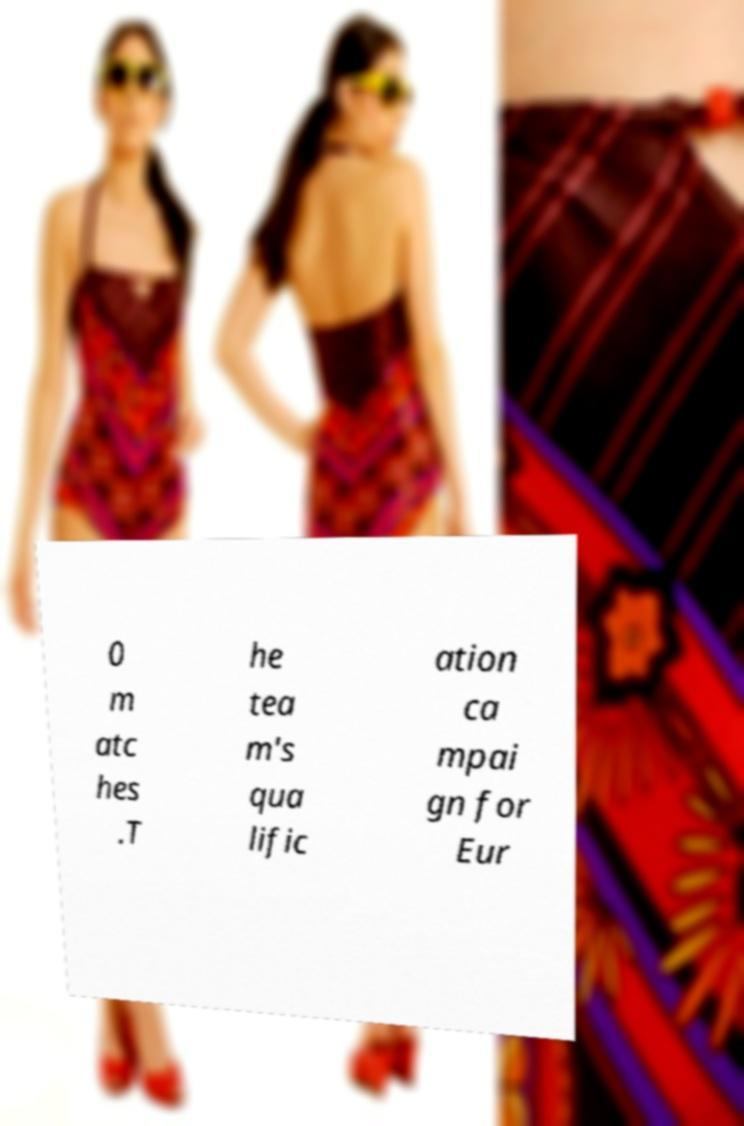There's text embedded in this image that I need extracted. Can you transcribe it verbatim? 0 m atc hes .T he tea m's qua lific ation ca mpai gn for Eur 